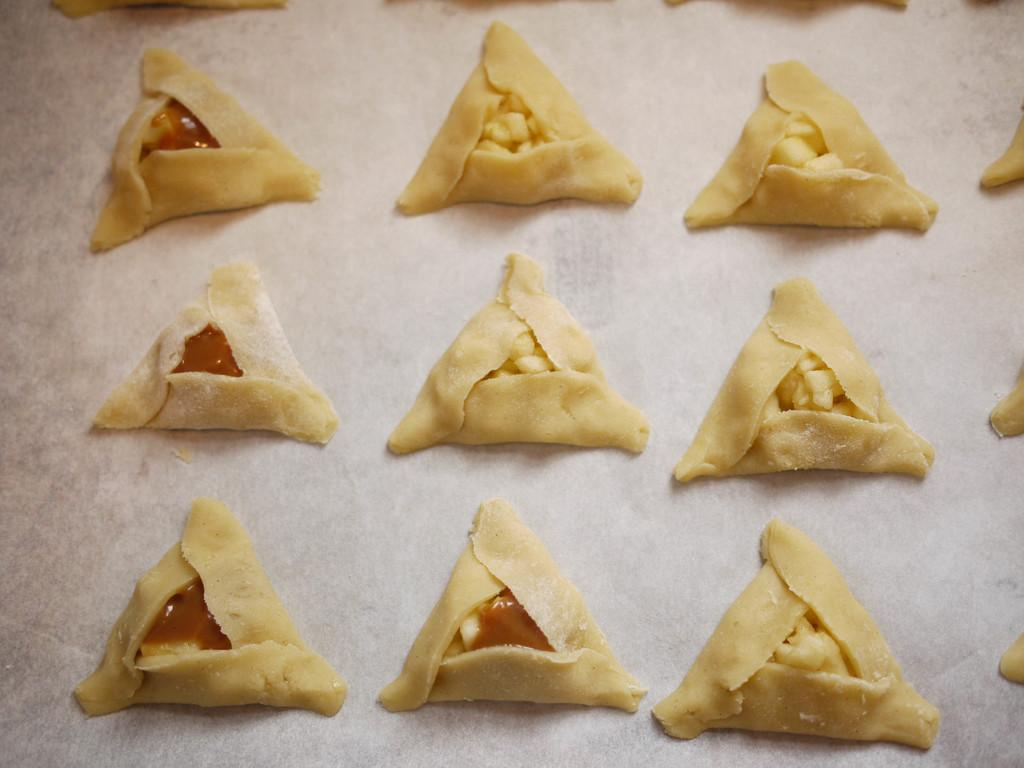What type of food is visible in the image? The image contains food, but the specific type is not mentioned in the facts. What is the surface at the bottom of the image made of? The surface at the bottom of the image is made of tiles. What is the name of the tooth that is visible in the image? There is no tooth present in the image. 